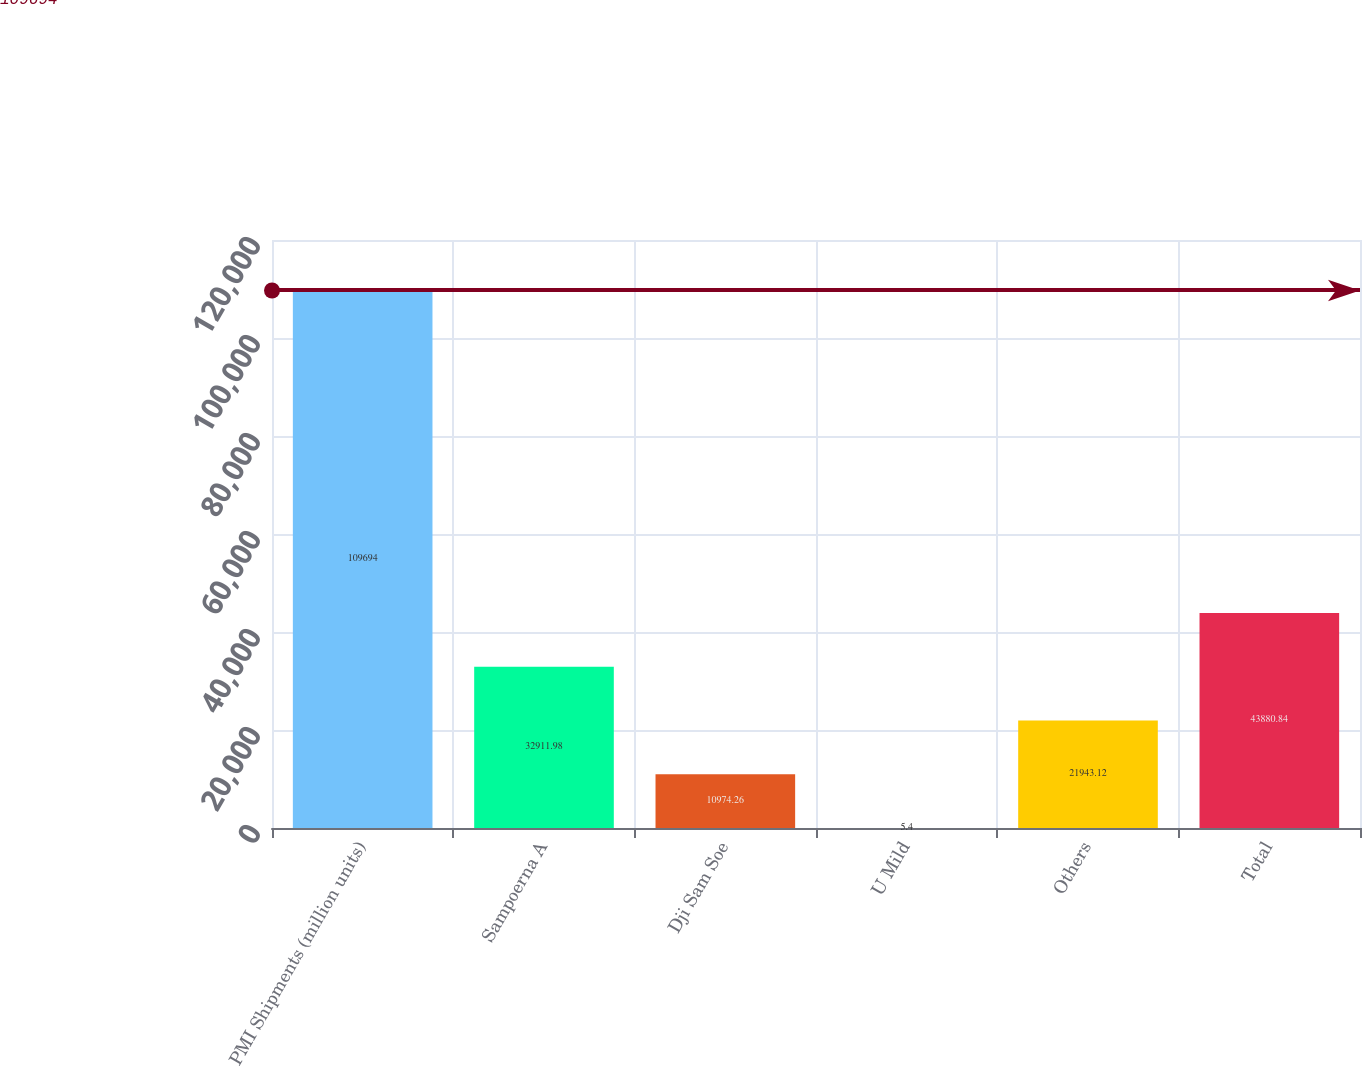Convert chart. <chart><loc_0><loc_0><loc_500><loc_500><bar_chart><fcel>PMI Shipments (million units)<fcel>Sampoerna A<fcel>Dji Sam Soe<fcel>U Mild<fcel>Others<fcel>Total<nl><fcel>109694<fcel>32912<fcel>10974.3<fcel>5.4<fcel>21943.1<fcel>43880.8<nl></chart> 